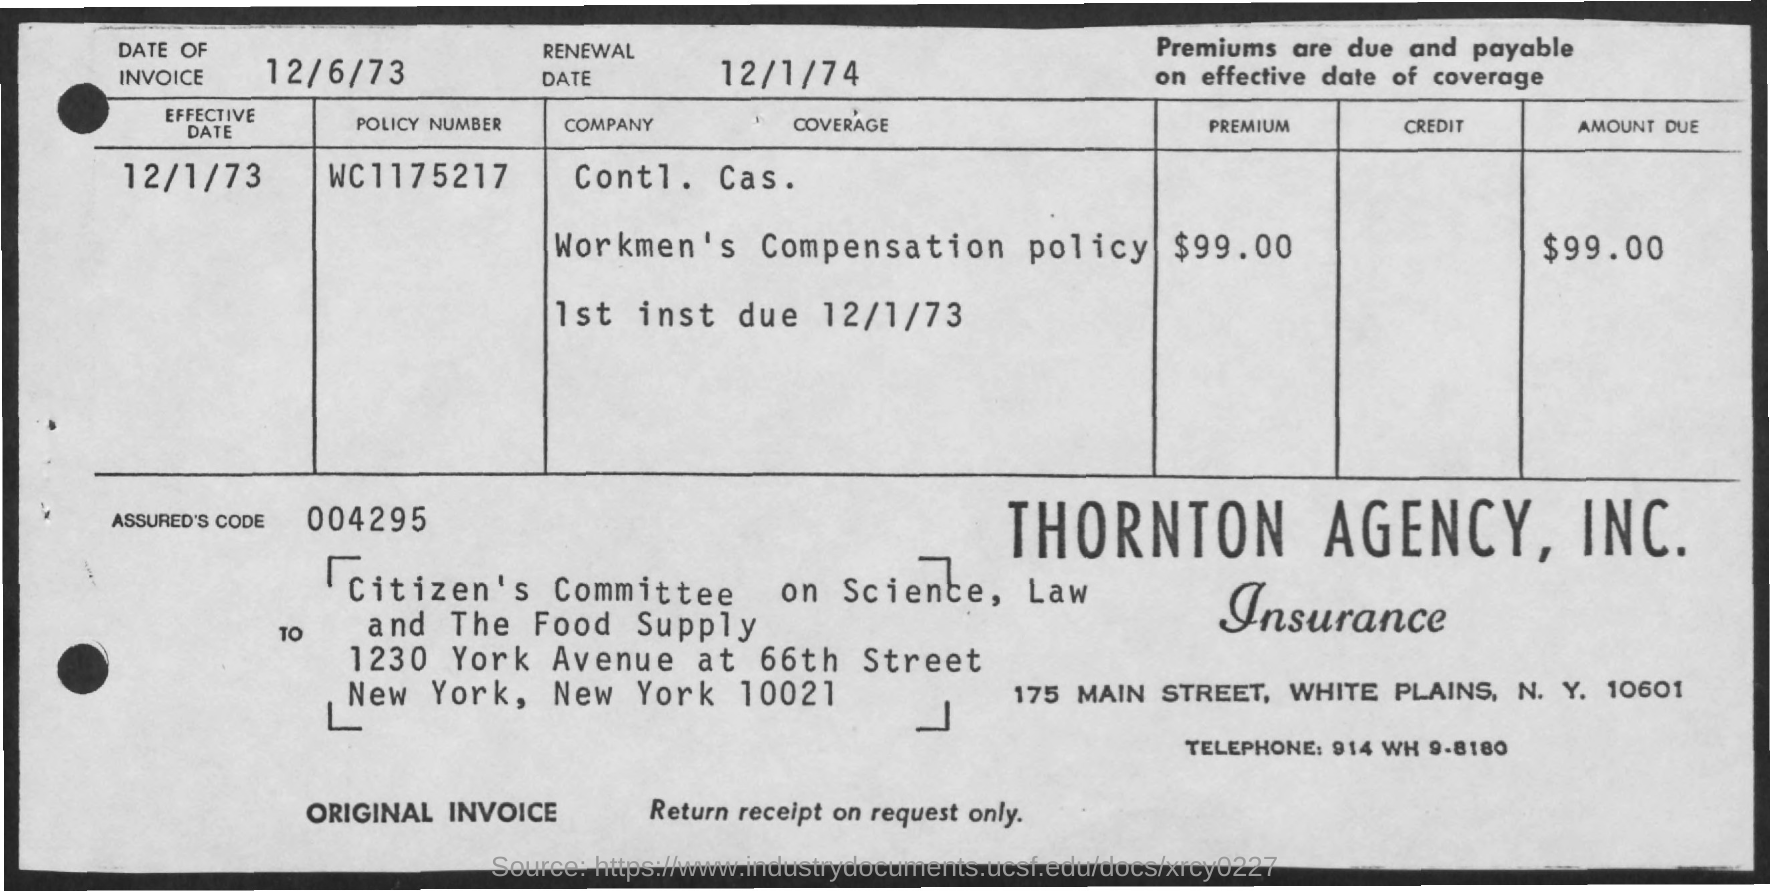What is the effective Date?
Offer a terse response. 12/1/73. What is the Premium?
Provide a succinct answer. $99.00. What is the Amount Due?
Ensure brevity in your answer.  $99.00. What is the Assured's code?
Your response must be concise. 004295. What is the Date of invoice?
Your answer should be compact. 12/6/73. What is the Renewal Date?
Offer a very short reply. 12/1/74. What is the Telephone?
Your response must be concise. 914 WH 9-8180. 